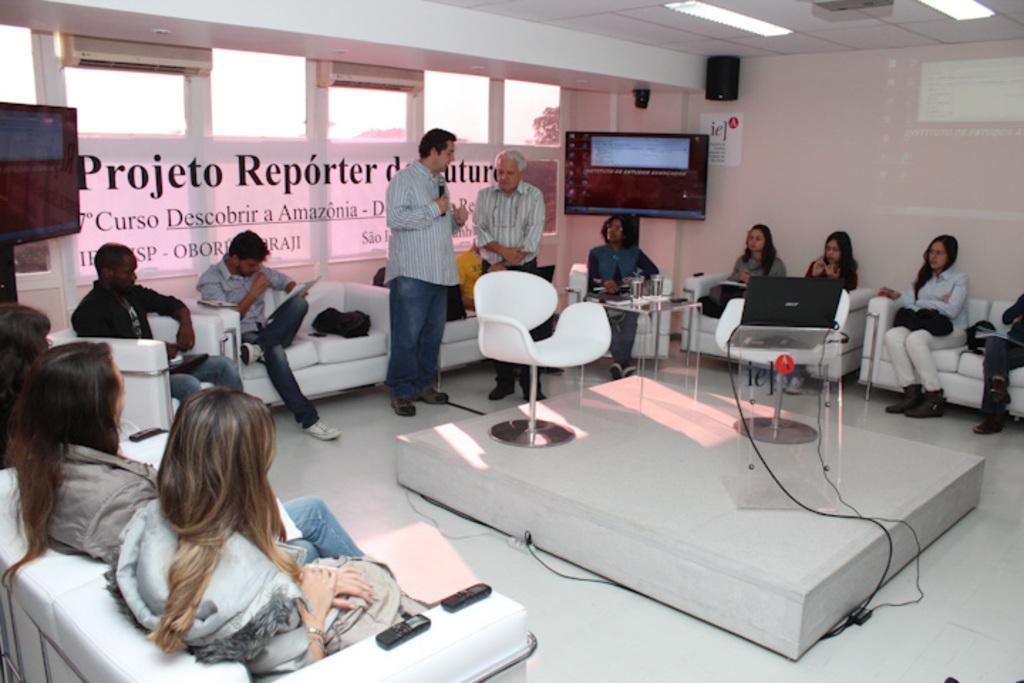In one or two sentences, can you explain what this image depicts? In this image few people are sitting on the chairs. Two persons at the middle of the image is standing. One person is holding a mike before them there are two chairs. One chair laptop is kept on it. Television is mounted onto the wall. 